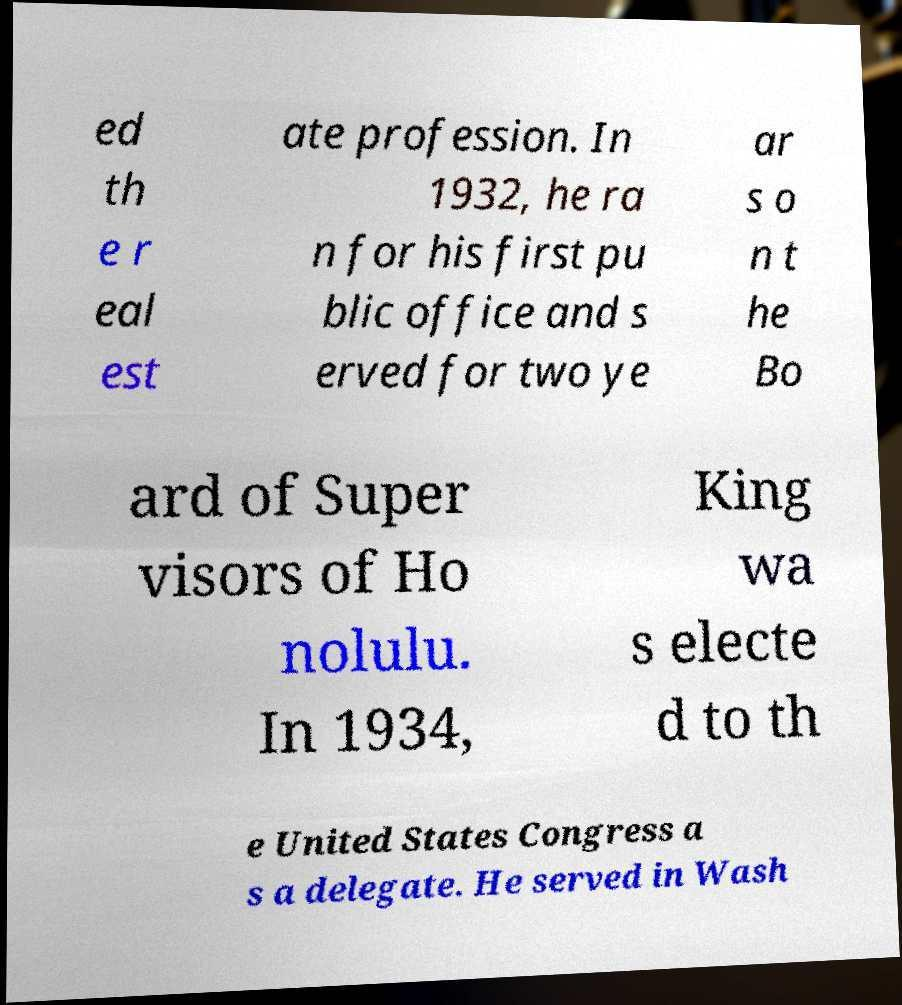Could you assist in decoding the text presented in this image and type it out clearly? ed th e r eal est ate profession. In 1932, he ra n for his first pu blic office and s erved for two ye ar s o n t he Bo ard of Super visors of Ho nolulu. In 1934, King wa s electe d to th e United States Congress a s a delegate. He served in Wash 